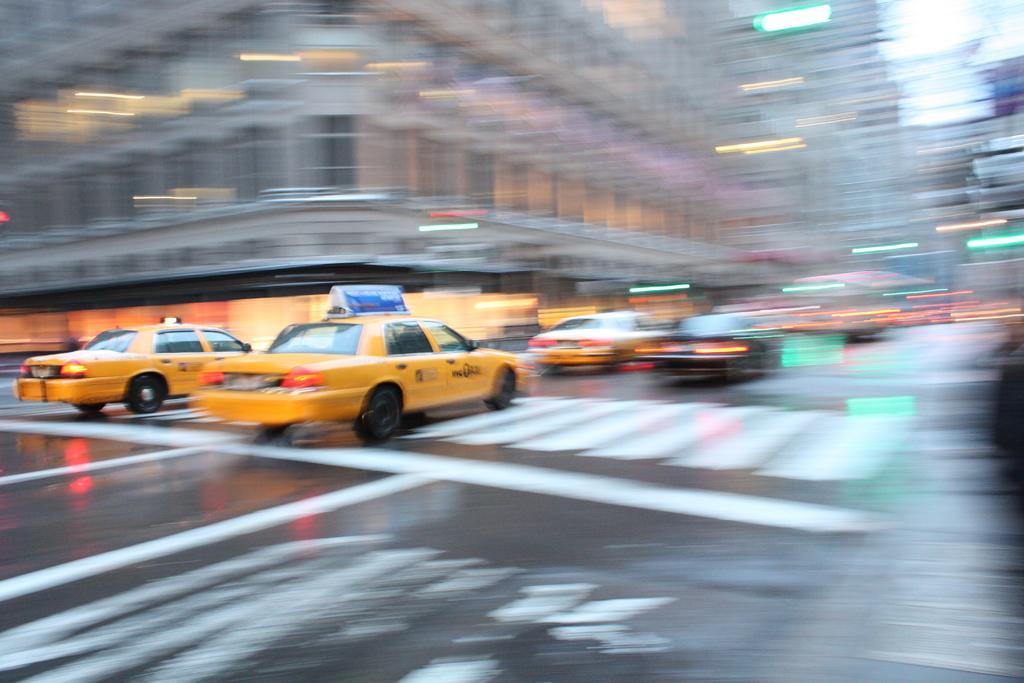Please provide a concise description of this image. In the center of the image there is a road on which there are vehicles. In the background of the image there are buildings. 